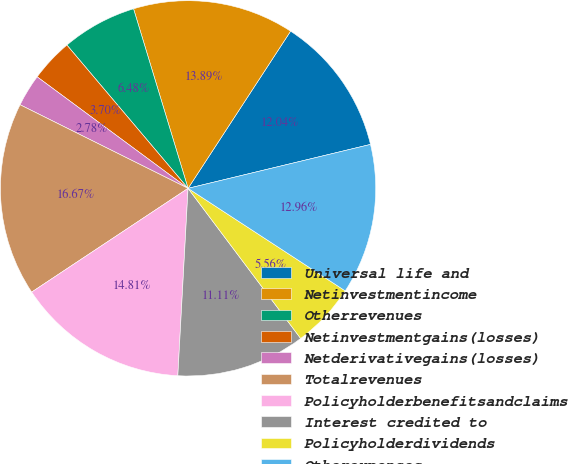<chart> <loc_0><loc_0><loc_500><loc_500><pie_chart><fcel>Universal life and<fcel>Netinvestmentincome<fcel>Otherrevenues<fcel>Netinvestmentgains(losses)<fcel>Netderivativegains(losses)<fcel>Totalrevenues<fcel>Policyholderbenefitsandclaims<fcel>Interest credited to<fcel>Policyholderdividends<fcel>Otherexpenses<nl><fcel>12.04%<fcel>13.89%<fcel>6.48%<fcel>3.7%<fcel>2.78%<fcel>16.67%<fcel>14.81%<fcel>11.11%<fcel>5.56%<fcel>12.96%<nl></chart> 